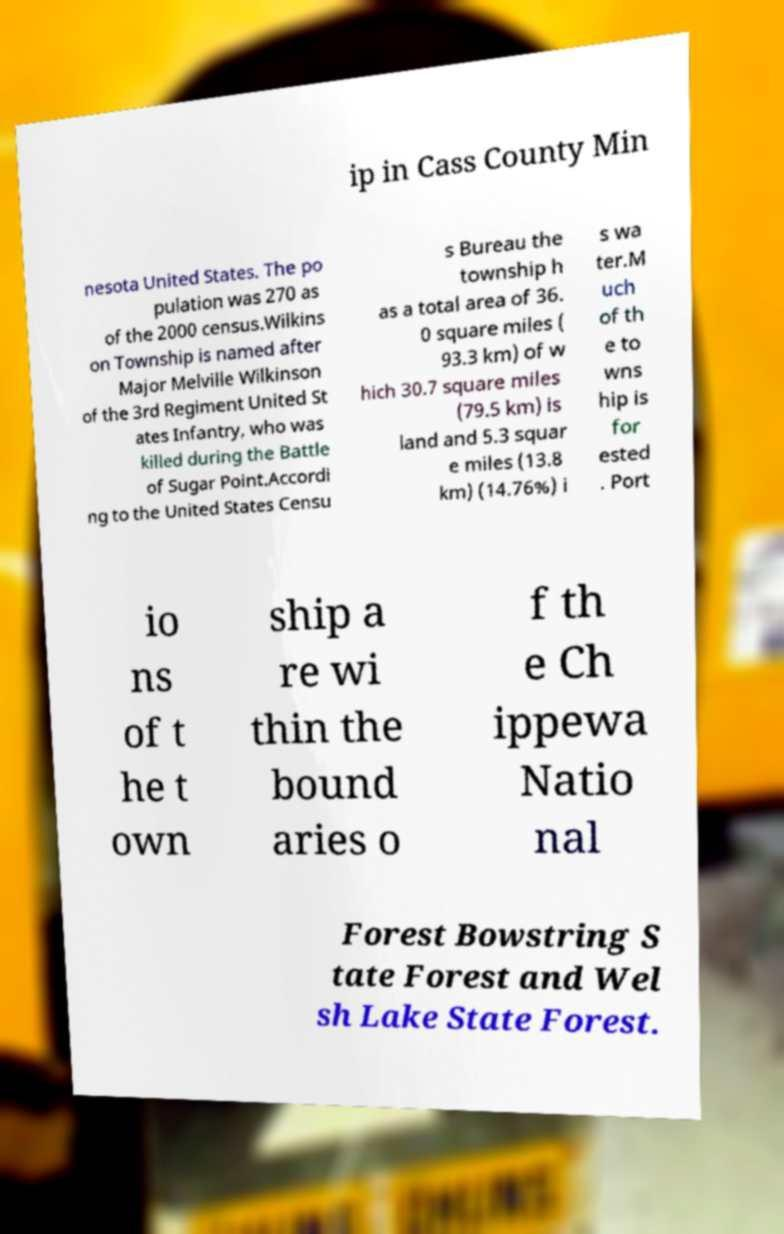Please identify and transcribe the text found in this image. ip in Cass County Min nesota United States. The po pulation was 270 as of the 2000 census.Wilkins on Township is named after Major Melville Wilkinson of the 3rd Regiment United St ates Infantry, who was killed during the Battle of Sugar Point.Accordi ng to the United States Censu s Bureau the township h as a total area of 36. 0 square miles ( 93.3 km) of w hich 30.7 square miles (79.5 km) is land and 5.3 squar e miles (13.8 km) (14.76%) i s wa ter.M uch of th e to wns hip is for ested . Port io ns of t he t own ship a re wi thin the bound aries o f th e Ch ippewa Natio nal Forest Bowstring S tate Forest and Wel sh Lake State Forest. 